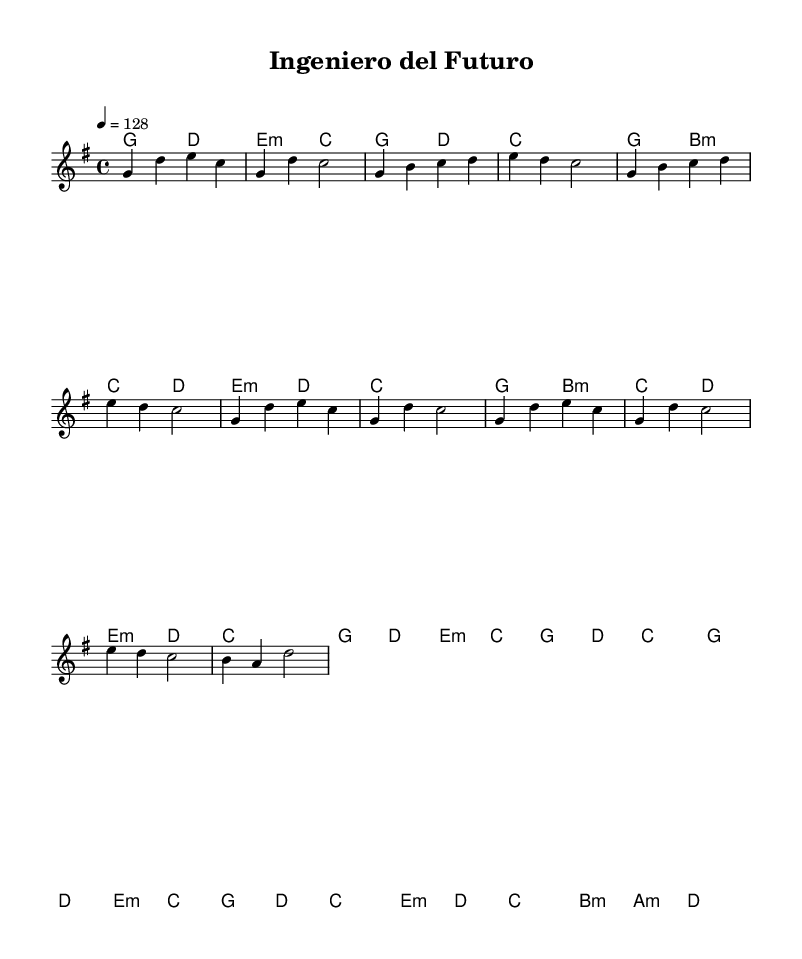What is the key signature of this music? The key signature is G major, which has one sharp (F#). This can be identified by looking at the key signature at the beginning of the staff.
Answer: G major What is the time signature of this piece? The time signature is 4/4, indicating there are four beats per measure and the quarter note receives one beat. This is shown at the beginning of the score right after the key signature.
Answer: 4/4 What is the tempo marking of this piece? The tempo marking is 128 beats per minute, indicated at the beginning of the score. The tempo is noted with the instruction "4 = 128."
Answer: 128 How many measures are in the chorus section? The chorus section consists of 4 measures, as seen in the layout of the repeated melodic and harmonic content specifically designated for the chorus.
Answer: 4 What type of chord is used in the bridge section? The bridge section includes minor chords, specifically E minor, D minor, and B minor, as indicated in the chord changes during that part of the piece.
Answer: Minor What is the main mood conveyed by the upbeat tempo and melody? The combination of the upbeat tempo and major key often conveys a celebratory and joyful mood, fitting for themes of academic achievement and personal growth, which is prevalent in the structure and feel of the music.
Answer: Celebratory 